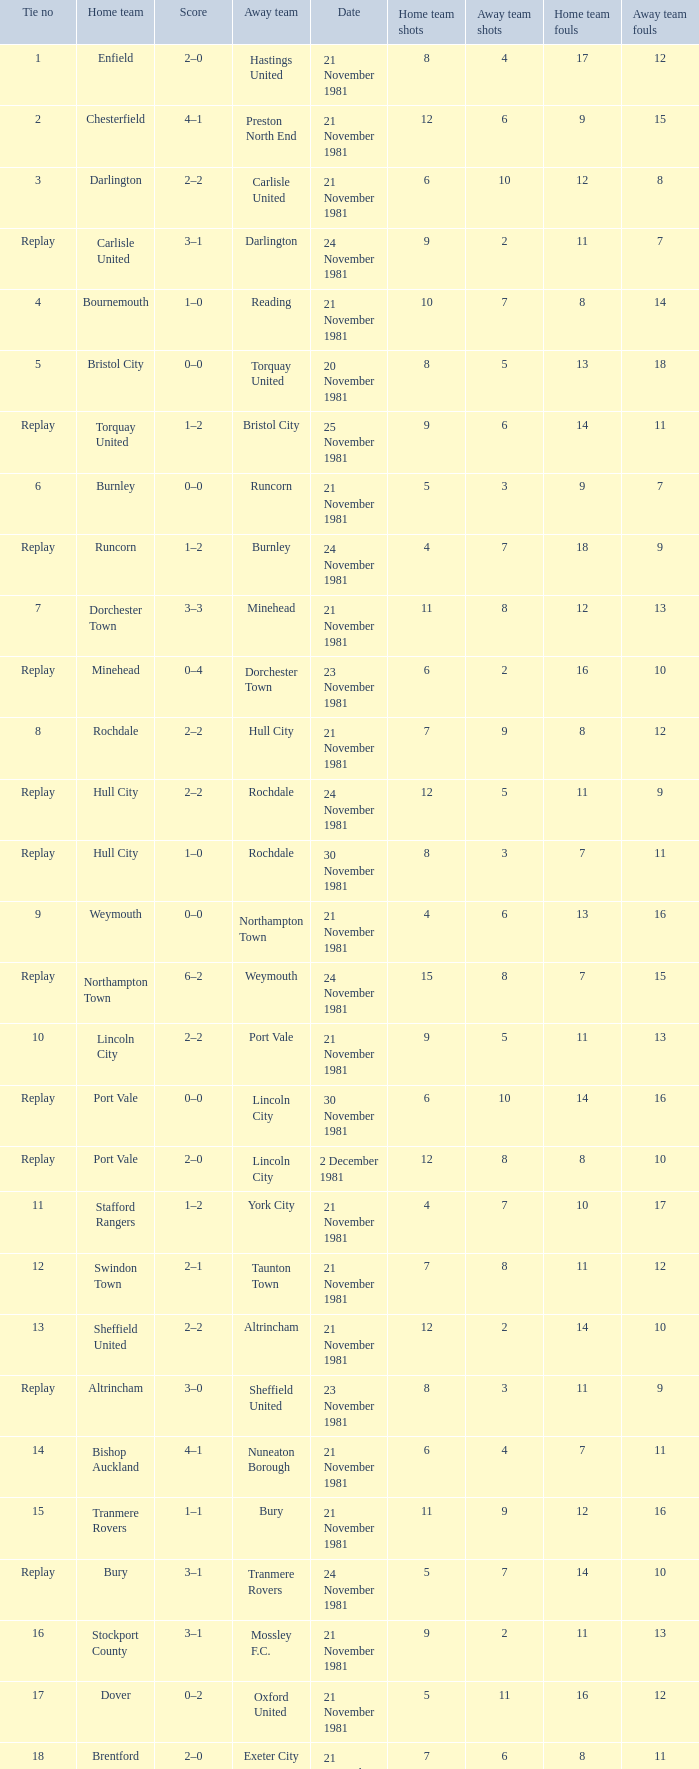What is enfield's tie number? 1.0. 